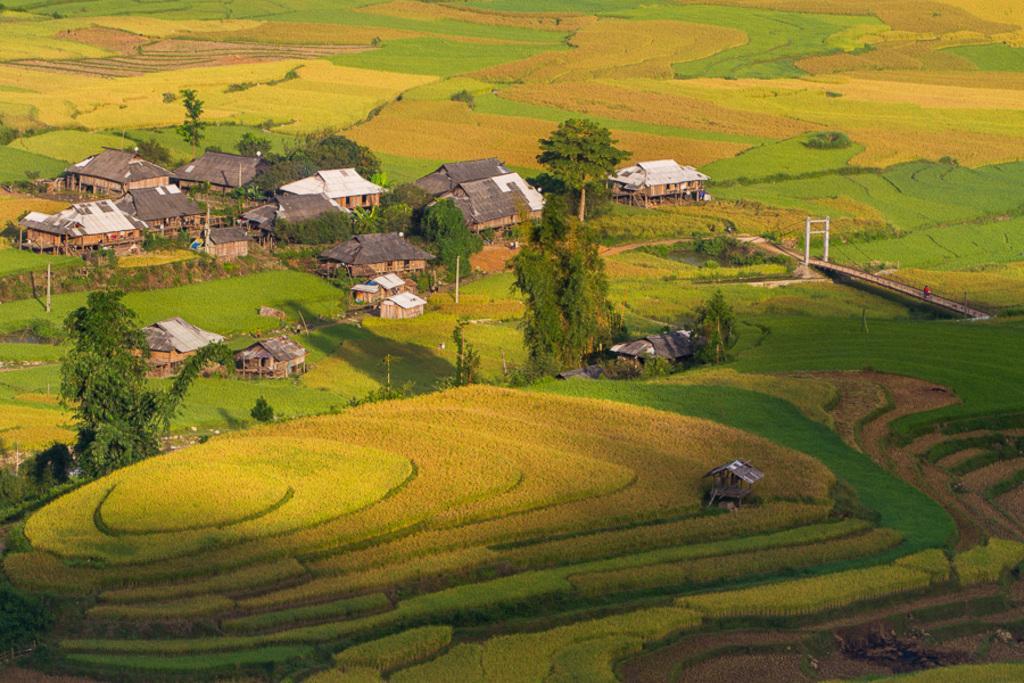Could you give a brief overview of what you see in this image? In this image we can see houses, trees, poles, grass, plants, person and bridge.   